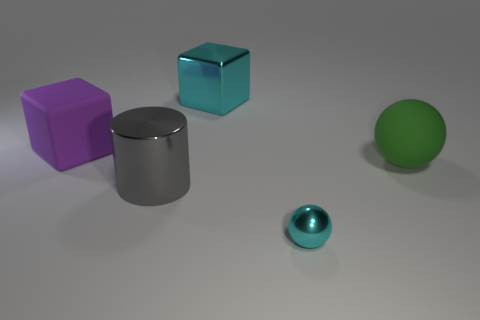How many other objects are the same material as the tiny cyan thing?
Provide a succinct answer. 2. Is there a metallic object in front of the rubber thing to the left of the gray cylinder?
Ensure brevity in your answer.  Yes. Are there any other things that are the same shape as the tiny cyan object?
Your response must be concise. Yes. The matte object that is the same shape as the big cyan metal object is what color?
Your answer should be compact. Purple. What is the size of the purple cube?
Give a very brief answer. Large. Are there fewer cyan shiny balls that are behind the big cyan cube than small cyan shiny objects?
Provide a short and direct response. Yes. Is the material of the tiny cyan object the same as the big thing right of the tiny cyan sphere?
Ensure brevity in your answer.  No. Are there any large green rubber things to the left of the large cube to the right of the big metal object in front of the big purple thing?
Offer a terse response. No. Is there any other thing that has the same size as the matte ball?
Your response must be concise. Yes. There is another big object that is made of the same material as the large green thing; what is its color?
Provide a succinct answer. Purple. 